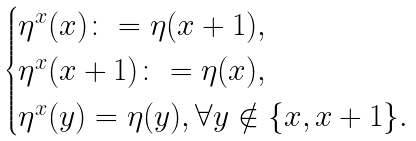Convert formula to latex. <formula><loc_0><loc_0><loc_500><loc_500>\begin{cases} \eta ^ { x } ( x ) \colon = \eta ( x + 1 ) , \\ \eta ^ { x } ( x + 1 ) \colon = \eta ( x ) , \\ \eta ^ { x } ( y ) = \eta ( y ) , \forall y \notin \{ x , x + 1 \} . \end{cases}</formula> 